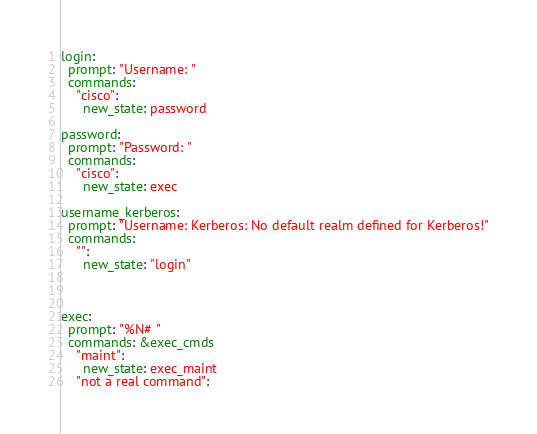Convert code to text. <code><loc_0><loc_0><loc_500><loc_500><_YAML_>
login:
  prompt: "Username: "
  commands:
    "cisco":
      new_state: password

password:
  prompt: "Password: "
  commands:
    "cisco":
      new_state: exec

username_kerberos:
  prompt: "Username: Kerberos: No default realm defined for Kerberos!"
  commands:
    "":
      new_state: "login"



exec:
  prompt: "%N# "
  commands: &exec_cmds
    "maint":
      new_state: exec_maint
    "not a real command":</code> 